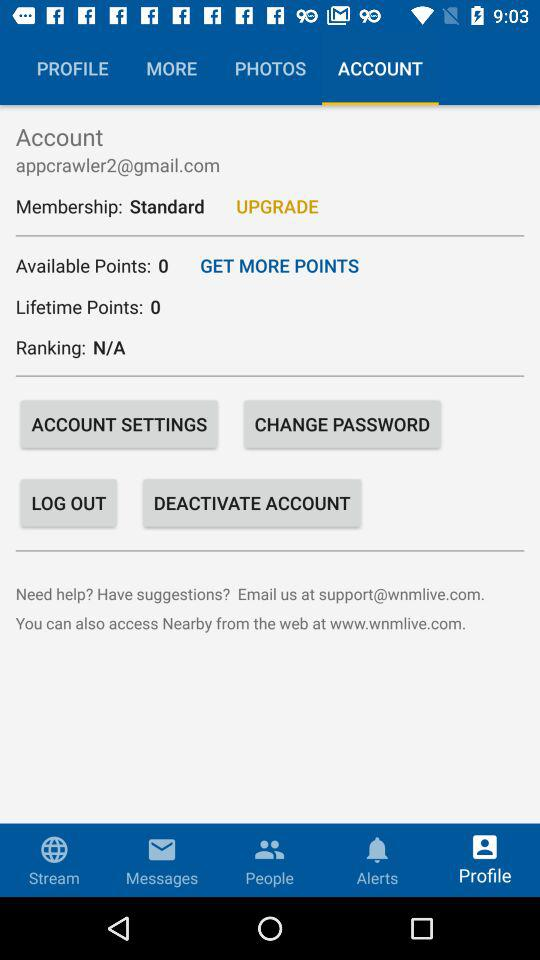What is the email address? The email address is "appcrawler2@gmail.com". 